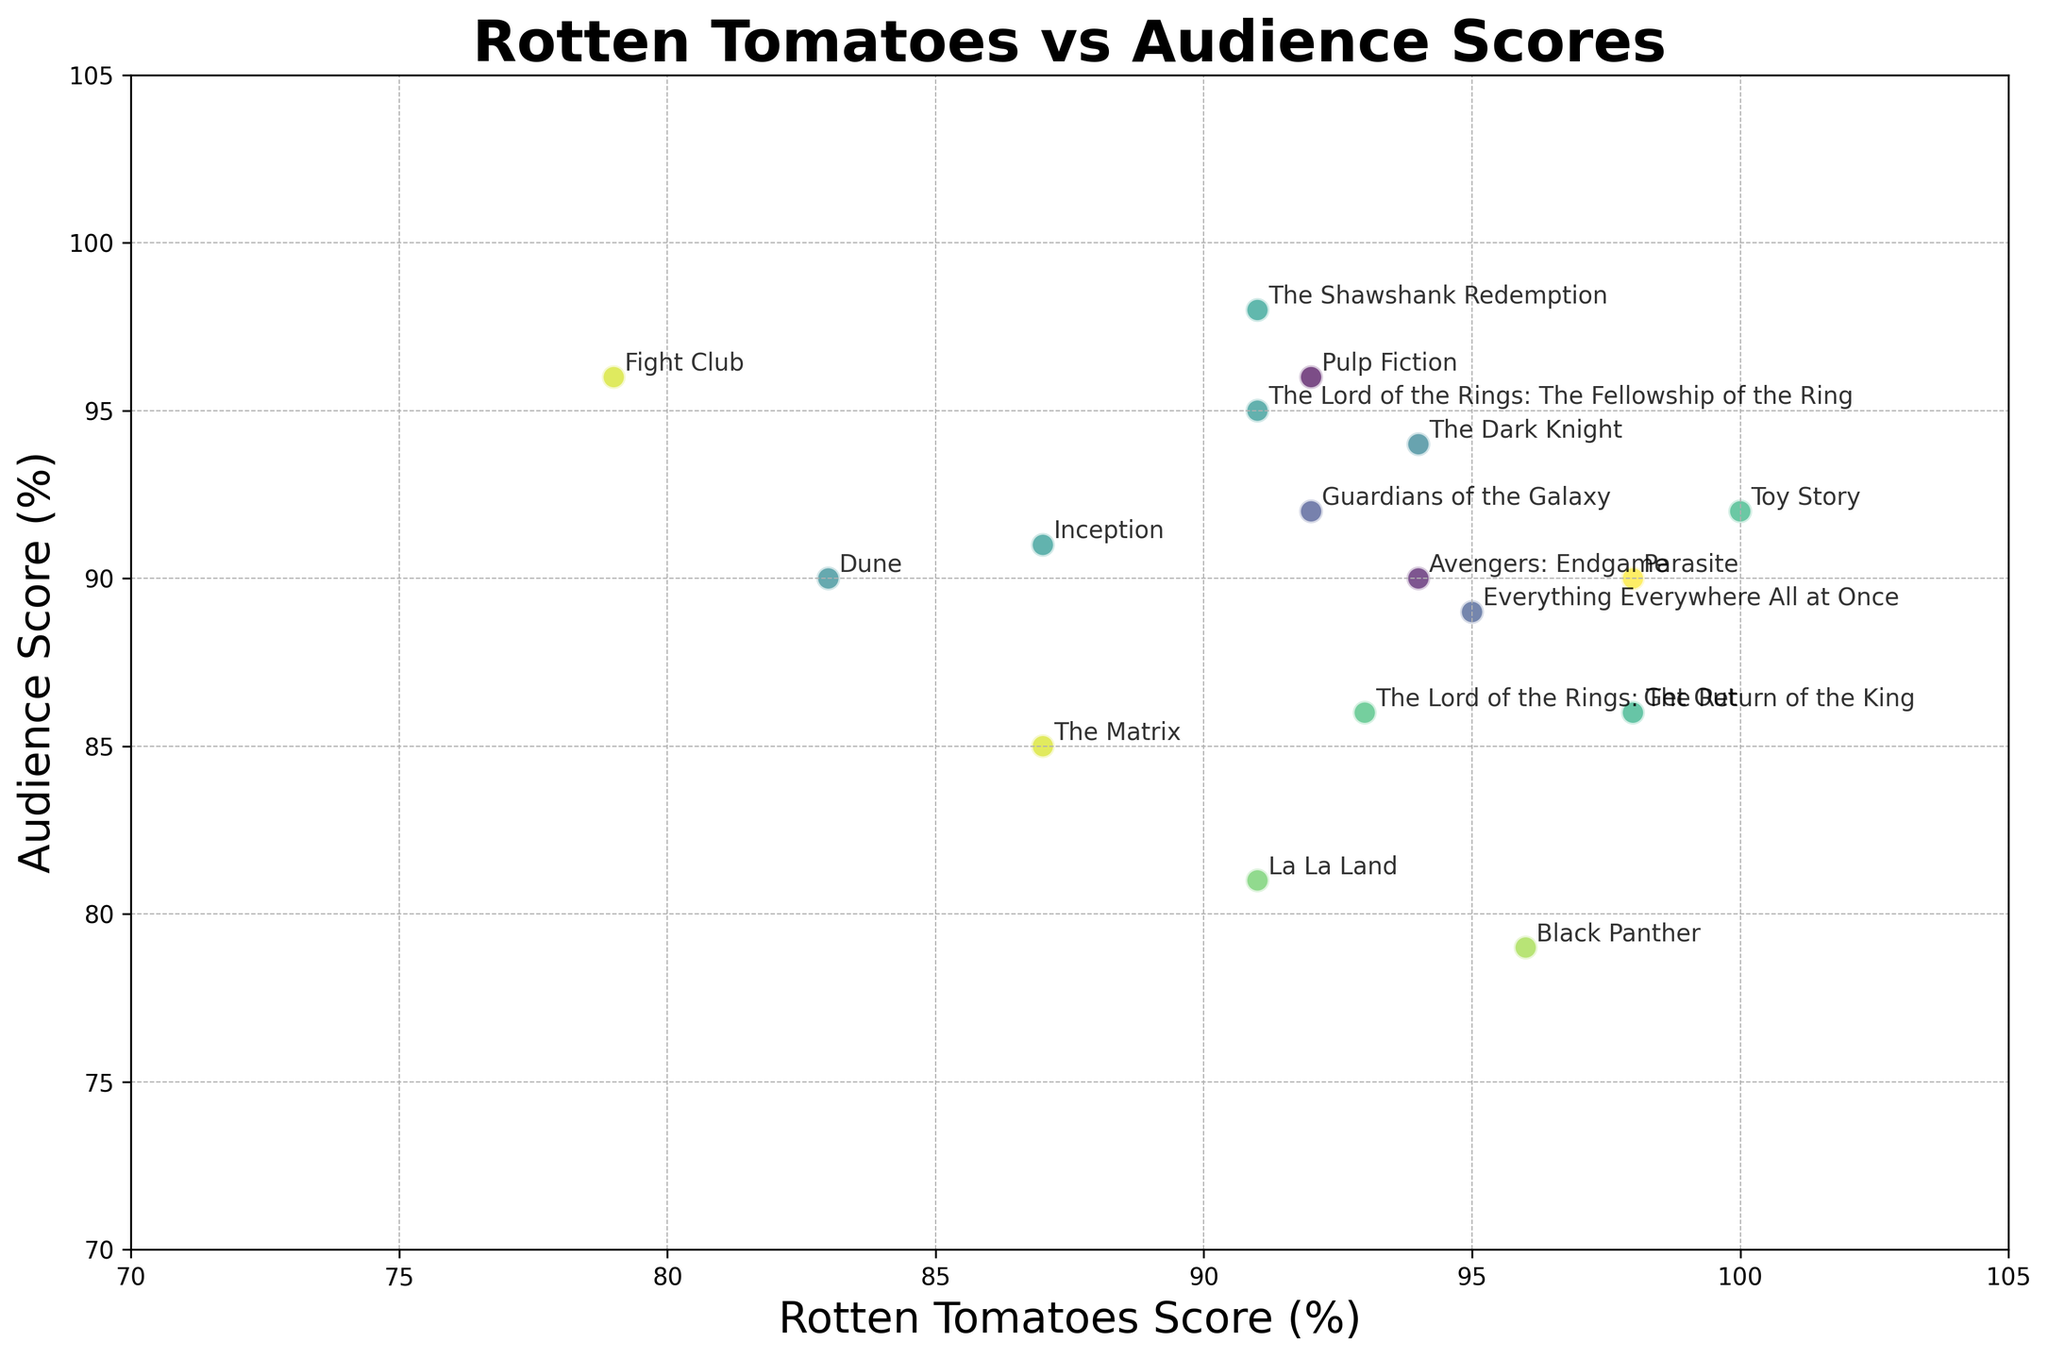which movie has the highest audience score? Observe the vertical axis (Audience Score) and find the point at the highest value. The annotation for this point shows "The Shawshank Redemption" with an audience score of 98.
Answer: The Shawshank Redemption which movie has the biggest difference between Rotten Tomatoes score and audience score? Calculate the absolute differences between Rotten Tomatoes scores and audience scores for each point, and identify the movie with the largest difference. "La La Land" has a Rotten Tomatoes score of 91 and an audience score of 81, resulting in a difference of 10.
Answer: La La Land which year's movie generally has higher Rotten Tomatoes scores: 2019 or 2020? Compare the Rotten Tomatoes scores for "Avengers: Endgame" in 2019 (94) and "Parasite" in 2020 (98).
Answer: 2020 which movies have equal Rotten Tomatoes and audience scores? Find points where the Rotten Tomatoes score and audience score are the same. "Guardians of the Galaxy" and "The Dark Knight" both have equal scores: 92 and 94 respectively.
Answer: Guardians of the Galaxy, The Dark Knight what's the average audience score for movies released in 2014 and later? Sum the audience scores for movies released in 2014 or later (92 + 81 + 86 + 79 + 90 + 90 + 89) and divide by the number of such movies (7). The average = (92 + 81 + 86 + 79 + 90 + 90 + 89) / 7 = 86.71
Answer: 86.71 how many movies have a Rotten Tomatoes score higher than 90? Count the number of titles where the Rotten Tomatoes score exceeds 90. The movies are "Pulp Fiction", "Toy Story", "The Lord of the Rings: The Return of the King", "Guardians of the Galaxy", "Get Out", "Black Panther", "Avengers: Endgame", "Parasite", "Everything Everywhere All at Once". This totals to 9.
Answer: 9 which movie has the lowest Rotten Tomatoes score and what is its audience score? Locate the movie with the lowest Rotten Tomatoes score using the horizontal axis. "Fight Club" has the lowest Rotten Tomatoes score (79) and an audience score of 96.
Answer: Fight Club, 96 compare the scores of "The Lord of the Rings: The Fellowship of the Ring" and "The Lord of the Rings: The Return of the King" "The Lord of the Rings: The Fellowship of the Ring" has a Rotten Tomatoes score of 91 and an audience score of 95, while "The Lord of the Rings: The Return of the King" has a Rotten Tomatoes score of 93 and an audience score of 86.
Answer: The Fellowship of the Ring has a lower Rotten Tomatoes score but higher audience score what's the average Rotten Tomatoes score for movies released after 2010? Sum the Rotten Tomatoes scores for movies released after 2010 (92 + 91 + 98 + 96 + 94 + 98 + 83 + 95) and divide by the number of such movies (8). The average = (92 + 91 + 98 + 96 + 94 + 98 + 83 + 95) / 8 = 93.375
Answer: 93.375 